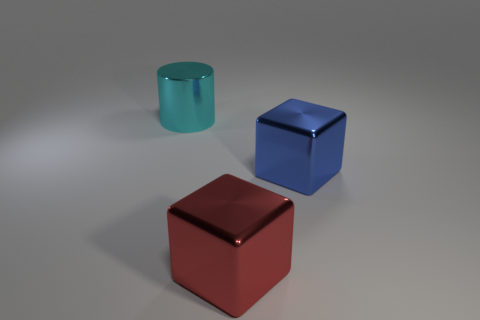There is a thing in front of the blue shiny thing; is its size the same as the big cyan object?
Your response must be concise. Yes. Is the number of metal cylinders that are on the left side of the cyan metal object the same as the number of cyan things that are in front of the blue shiny cube?
Provide a short and direct response. Yes. What is the color of the big thing that is behind the big shiny block that is behind the large object that is in front of the blue object?
Keep it short and to the point. Cyan. What is the shape of the big shiny object in front of the large blue block?
Your answer should be compact. Cube. There is a cyan object that is the same material as the big red cube; what shape is it?
Offer a very short reply. Cylinder. Is there anything else that is the same shape as the large cyan metal thing?
Your answer should be very brief. No. There is a big red block; how many blue blocks are to the right of it?
Offer a very short reply. 1. Is the number of large cubes that are on the right side of the large red object the same as the number of big gray rubber blocks?
Offer a very short reply. No. Does the blue cube have the same material as the big red thing?
Keep it short and to the point. Yes. There is a metal thing that is behind the big red shiny thing and on the right side of the large cyan metallic cylinder; what size is it?
Provide a short and direct response. Large. 